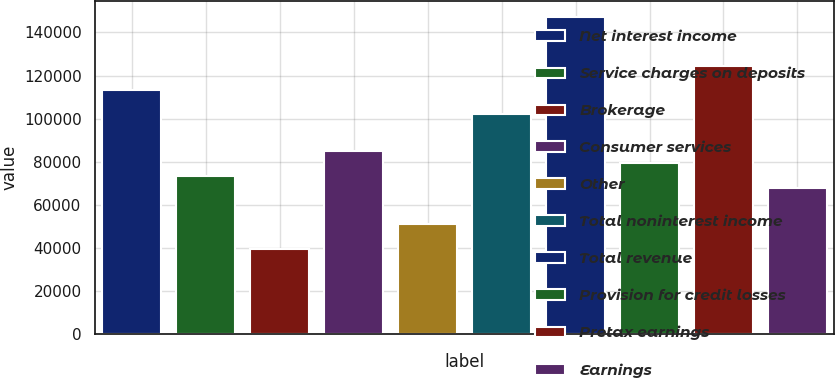Convert chart. <chart><loc_0><loc_0><loc_500><loc_500><bar_chart><fcel>Net interest income<fcel>Service charges on deposits<fcel>Brokerage<fcel>Consumer services<fcel>Other<fcel>Total noninterest income<fcel>Total revenue<fcel>Provision for credit losses<fcel>Pretax earnings<fcel>Earnings<nl><fcel>113262<fcel>73620.9<fcel>39643.1<fcel>84946.9<fcel>50969<fcel>101936<fcel>147240<fcel>79283.9<fcel>124588<fcel>67957.9<nl></chart> 